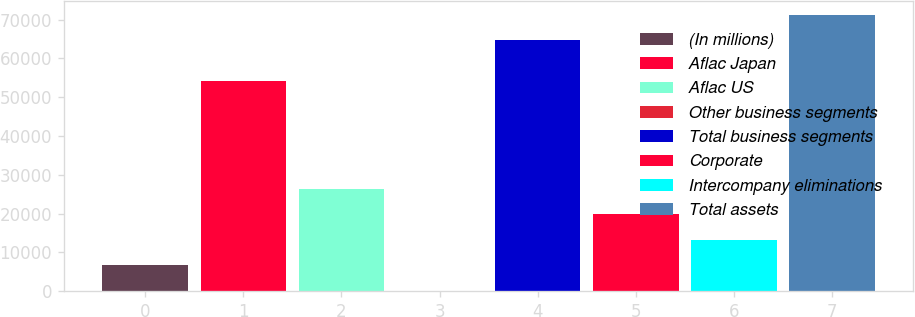<chart> <loc_0><loc_0><loc_500><loc_500><bar_chart><fcel>(In millions)<fcel>Aflac Japan<fcel>Aflac US<fcel>Other business segments<fcel>Total business segments<fcel>Corporate<fcel>Intercompany eliminations<fcel>Total assets<nl><fcel>6685.8<fcel>54153<fcel>26392.2<fcel>117<fcel>64685<fcel>19823.4<fcel>13254.6<fcel>71253.8<nl></chart> 